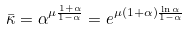<formula> <loc_0><loc_0><loc_500><loc_500>\bar { \kappa } = \alpha ^ { \mu \frac { 1 + \alpha } { 1 - \alpha } } = e ^ { \mu ( 1 + \alpha ) \frac { \ln \alpha } { 1 - \alpha } }</formula> 